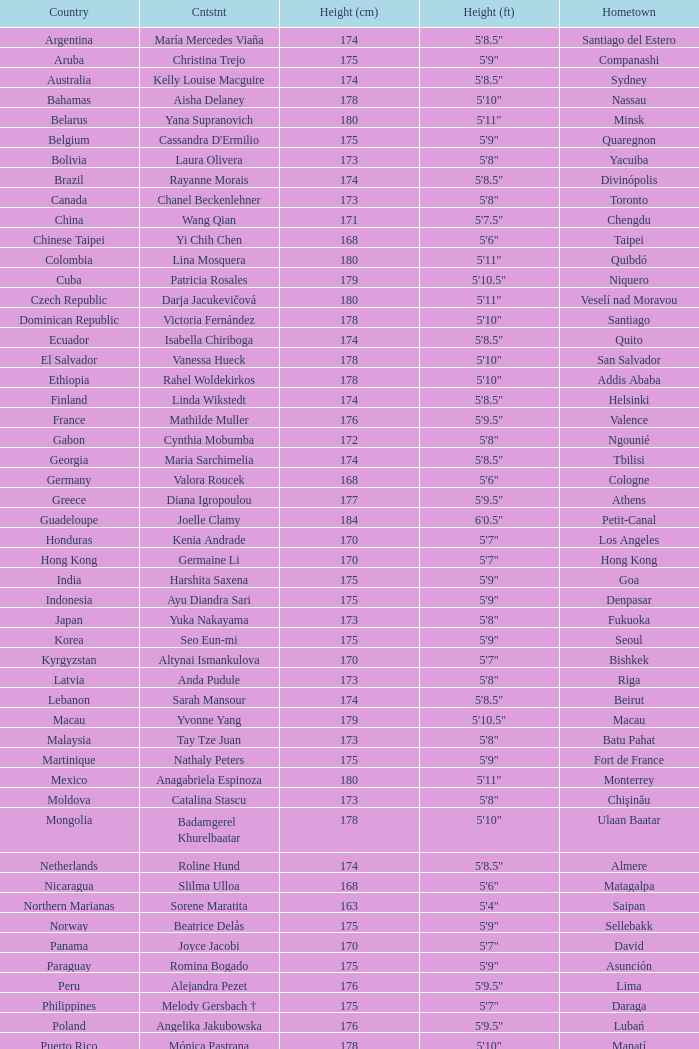What is the hometown of the player from Indonesia? Denpasar. 